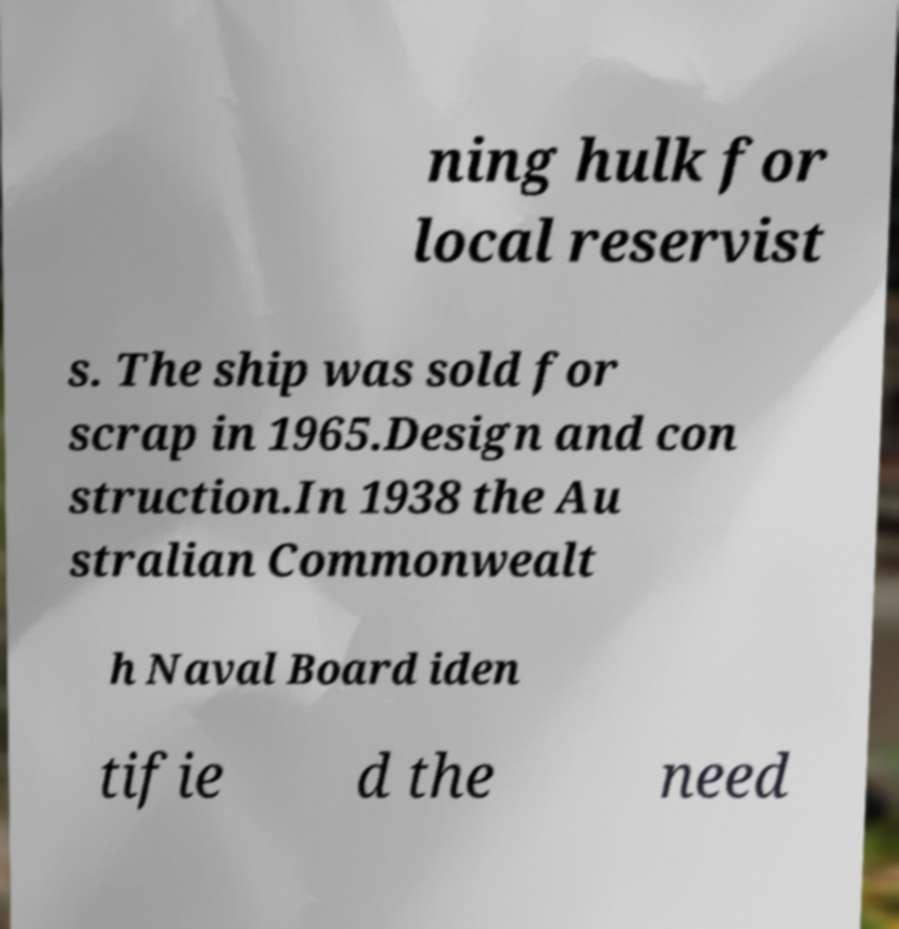Please read and relay the text visible in this image. What does it say? ning hulk for local reservist s. The ship was sold for scrap in 1965.Design and con struction.In 1938 the Au stralian Commonwealt h Naval Board iden tifie d the need 